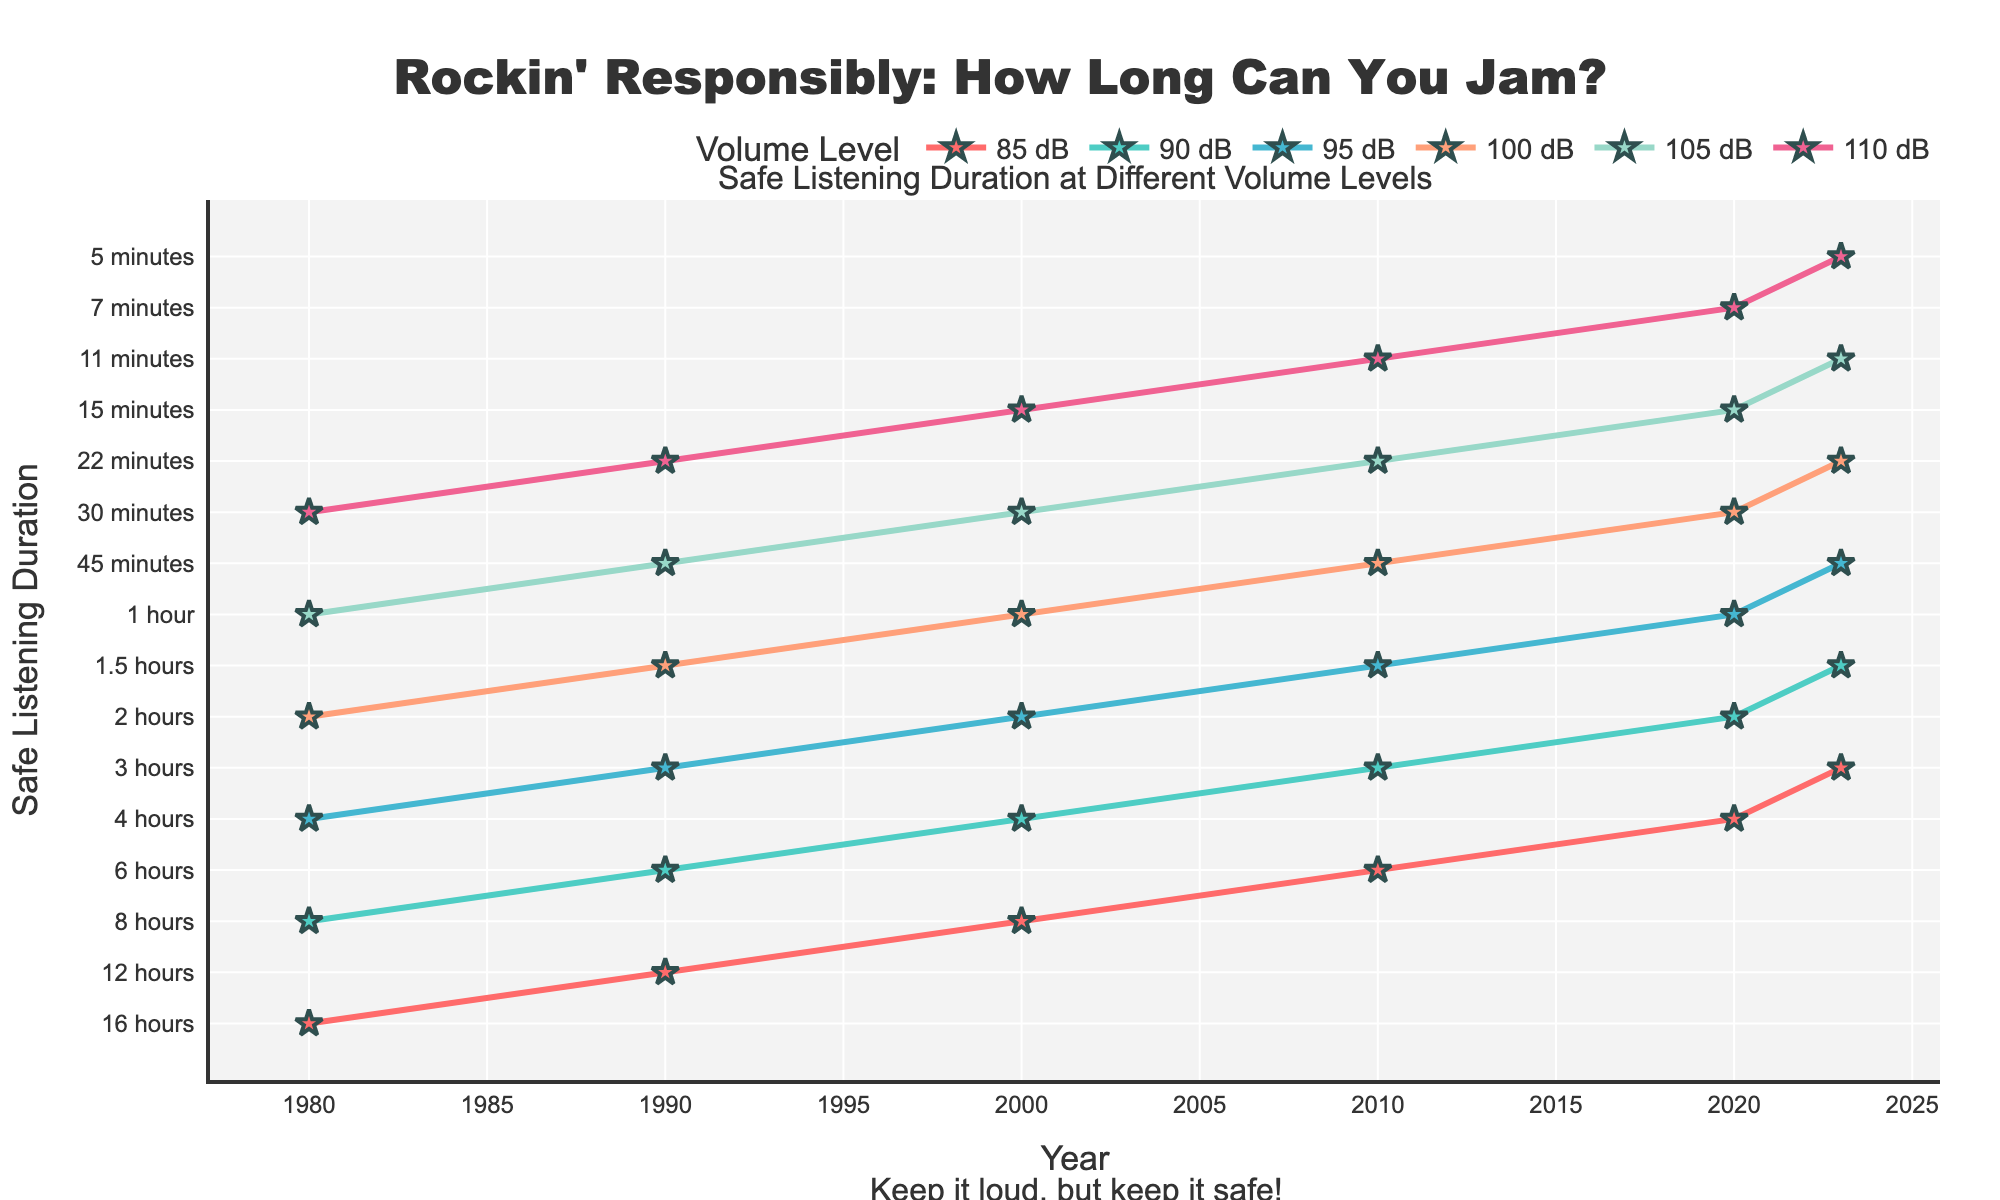what has been the trend in safe listening duration for a volume level of 85 dB from 1980 to 2023? To find the trend, observe the line for 85 dB across the years. It starts at 16 hours in 1980 and gradually decreases to 3 hours in 2023. This indicates a consistent decrease over time.
Answer: Consistent decrease Which volume level showed the steepest decline in safe listening duration between 1980 and 2023? Compare the slopes of the lines for each volume level. The safest duration at 110 dB starts at 30 minutes in 1980 and drops to 5 minutes in 2023. This large drop in a short time suggests the steepest decline.
Answer: 110 dB By how much did the safe listening duration decrease for 90 dB between 1990 and 2023? Check the values for 90 dB in 1990 and 2023. In 1990, it was 6 hours, and in 2023, it was 1.5 hours. The decrease is calculated as 6 hours - 1.5 hours = 4.5 hours.
Answer: 4.5 hours In 2000, which volume levels had a safe listening duration of 1 hour or less? Look for the values equal to or less than 1 hour in 2000. The durations are: 95 dB (2 hours), 100 dB (1 hour), 105 dB (30 minutes), 110 dB (15 minutes). Only 100 dB, 105 dB, and 110 dB meet this criterion.
Answer: 100 dB, 105 dB, 110 dB Which year saw the greatest reduction in safe listening duration across all volume levels? Compare the reductions between consecutive years for each volume level. Notice that from 1990 to 2000, there were significant decreases across multiple levels, making this period the greatest reduction.
Answer: 2000 Calculate the average safe listening duration for the year 2010 for all volume levels. Add the safe durations for all levels in 2010 and divide by the number of levels: (6 hours + 3 hours + 1.5 hours + 45 minutes + 22 minutes + 11 minutes). Convert all to hours: 6 + 3 + 1.5 + 0.75 + 0.367 + 0.183. The sum is approximately 11.80 hours. Average is 11.80 / 6 ≈ 1.97 hours.
Answer: 1.97 hours How do the safe listening durations at 85 dB differ between 1980 and 2023? Compare the values: 1980 had 16 hours and 2023 had 3 hours. The difference is calculated as 16 - 3 = 13 hours.
Answer: 13 hours What is the color representing the 100 dB volume level on the plot? Check the visual representation for each volume level label. 100 dB uses a color that appears as a light orange or salmon shade.
Answer: Light orange 